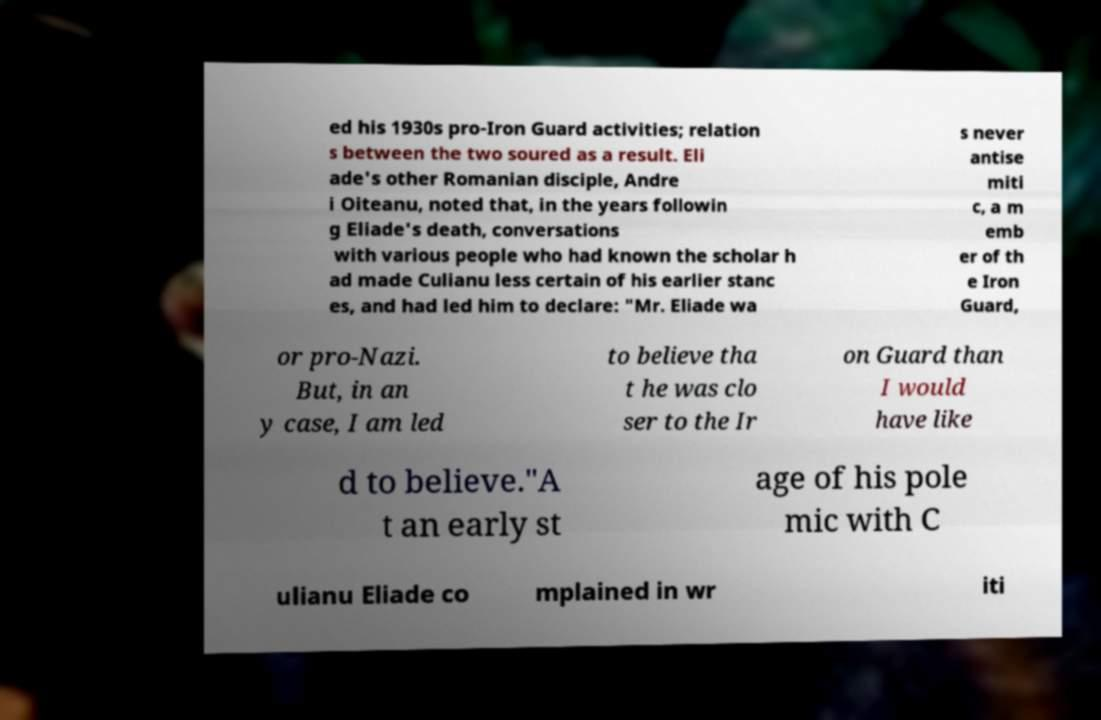Could you assist in decoding the text presented in this image and type it out clearly? ed his 1930s pro-Iron Guard activities; relation s between the two soured as a result. Eli ade's other Romanian disciple, Andre i Oiteanu, noted that, in the years followin g Eliade's death, conversations with various people who had known the scholar h ad made Culianu less certain of his earlier stanc es, and had led him to declare: "Mr. Eliade wa s never antise miti c, a m emb er of th e Iron Guard, or pro-Nazi. But, in an y case, I am led to believe tha t he was clo ser to the Ir on Guard than I would have like d to believe."A t an early st age of his pole mic with C ulianu Eliade co mplained in wr iti 